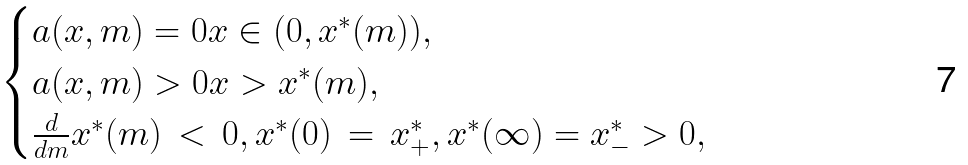<formula> <loc_0><loc_0><loc_500><loc_500>\begin{cases} a ( x , m ) = 0 x \in ( 0 , x ^ { * } ( m ) ) , \\ a ( x , m ) > 0 x > x ^ { * } ( m ) , \\ \frac { d } { d m } x ^ { * } ( m ) \, < \, 0 , x ^ { * } ( 0 ) \, = \, x ^ { * } _ { + } , x ^ { * } ( \infty ) = x ^ { * } _ { - } > 0 , \end{cases}</formula> 